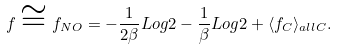Convert formula to latex. <formula><loc_0><loc_0><loc_500><loc_500>f \cong f _ { N O } = - \frac { 1 } { 2 \beta } L o g 2 - \frac { 1 } { \beta } L o g 2 + \langle f _ { C } \rangle _ { a l l C } .</formula> 